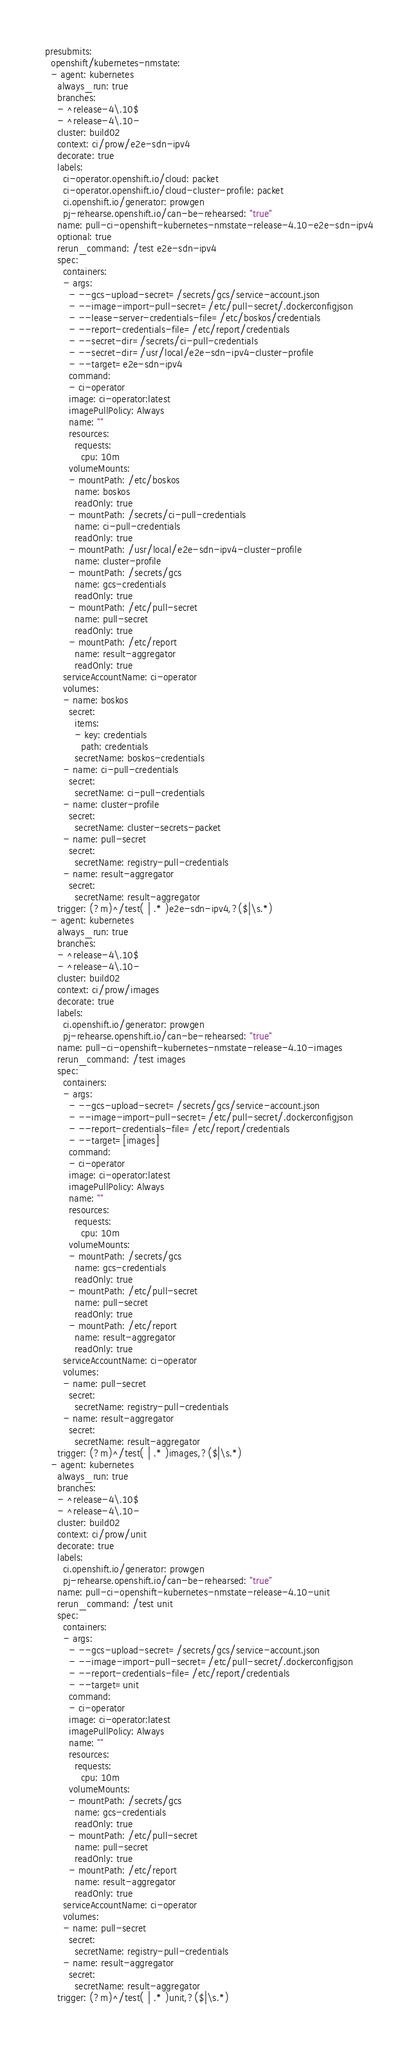<code> <loc_0><loc_0><loc_500><loc_500><_YAML_>presubmits:
  openshift/kubernetes-nmstate:
  - agent: kubernetes
    always_run: true
    branches:
    - ^release-4\.10$
    - ^release-4\.10-
    cluster: build02
    context: ci/prow/e2e-sdn-ipv4
    decorate: true
    labels:
      ci-operator.openshift.io/cloud: packet
      ci-operator.openshift.io/cloud-cluster-profile: packet
      ci.openshift.io/generator: prowgen
      pj-rehearse.openshift.io/can-be-rehearsed: "true"
    name: pull-ci-openshift-kubernetes-nmstate-release-4.10-e2e-sdn-ipv4
    optional: true
    rerun_command: /test e2e-sdn-ipv4
    spec:
      containers:
      - args:
        - --gcs-upload-secret=/secrets/gcs/service-account.json
        - --image-import-pull-secret=/etc/pull-secret/.dockerconfigjson
        - --lease-server-credentials-file=/etc/boskos/credentials
        - --report-credentials-file=/etc/report/credentials
        - --secret-dir=/secrets/ci-pull-credentials
        - --secret-dir=/usr/local/e2e-sdn-ipv4-cluster-profile
        - --target=e2e-sdn-ipv4
        command:
        - ci-operator
        image: ci-operator:latest
        imagePullPolicy: Always
        name: ""
        resources:
          requests:
            cpu: 10m
        volumeMounts:
        - mountPath: /etc/boskos
          name: boskos
          readOnly: true
        - mountPath: /secrets/ci-pull-credentials
          name: ci-pull-credentials
          readOnly: true
        - mountPath: /usr/local/e2e-sdn-ipv4-cluster-profile
          name: cluster-profile
        - mountPath: /secrets/gcs
          name: gcs-credentials
          readOnly: true
        - mountPath: /etc/pull-secret
          name: pull-secret
          readOnly: true
        - mountPath: /etc/report
          name: result-aggregator
          readOnly: true
      serviceAccountName: ci-operator
      volumes:
      - name: boskos
        secret:
          items:
          - key: credentials
            path: credentials
          secretName: boskos-credentials
      - name: ci-pull-credentials
        secret:
          secretName: ci-pull-credentials
      - name: cluster-profile
        secret:
          secretName: cluster-secrets-packet
      - name: pull-secret
        secret:
          secretName: registry-pull-credentials
      - name: result-aggregator
        secret:
          secretName: result-aggregator
    trigger: (?m)^/test( | .* )e2e-sdn-ipv4,?($|\s.*)
  - agent: kubernetes
    always_run: true
    branches:
    - ^release-4\.10$
    - ^release-4\.10-
    cluster: build02
    context: ci/prow/images
    decorate: true
    labels:
      ci.openshift.io/generator: prowgen
      pj-rehearse.openshift.io/can-be-rehearsed: "true"
    name: pull-ci-openshift-kubernetes-nmstate-release-4.10-images
    rerun_command: /test images
    spec:
      containers:
      - args:
        - --gcs-upload-secret=/secrets/gcs/service-account.json
        - --image-import-pull-secret=/etc/pull-secret/.dockerconfigjson
        - --report-credentials-file=/etc/report/credentials
        - --target=[images]
        command:
        - ci-operator
        image: ci-operator:latest
        imagePullPolicy: Always
        name: ""
        resources:
          requests:
            cpu: 10m
        volumeMounts:
        - mountPath: /secrets/gcs
          name: gcs-credentials
          readOnly: true
        - mountPath: /etc/pull-secret
          name: pull-secret
          readOnly: true
        - mountPath: /etc/report
          name: result-aggregator
          readOnly: true
      serviceAccountName: ci-operator
      volumes:
      - name: pull-secret
        secret:
          secretName: registry-pull-credentials
      - name: result-aggregator
        secret:
          secretName: result-aggregator
    trigger: (?m)^/test( | .* )images,?($|\s.*)
  - agent: kubernetes
    always_run: true
    branches:
    - ^release-4\.10$
    - ^release-4\.10-
    cluster: build02
    context: ci/prow/unit
    decorate: true
    labels:
      ci.openshift.io/generator: prowgen
      pj-rehearse.openshift.io/can-be-rehearsed: "true"
    name: pull-ci-openshift-kubernetes-nmstate-release-4.10-unit
    rerun_command: /test unit
    spec:
      containers:
      - args:
        - --gcs-upload-secret=/secrets/gcs/service-account.json
        - --image-import-pull-secret=/etc/pull-secret/.dockerconfigjson
        - --report-credentials-file=/etc/report/credentials
        - --target=unit
        command:
        - ci-operator
        image: ci-operator:latest
        imagePullPolicy: Always
        name: ""
        resources:
          requests:
            cpu: 10m
        volumeMounts:
        - mountPath: /secrets/gcs
          name: gcs-credentials
          readOnly: true
        - mountPath: /etc/pull-secret
          name: pull-secret
          readOnly: true
        - mountPath: /etc/report
          name: result-aggregator
          readOnly: true
      serviceAccountName: ci-operator
      volumes:
      - name: pull-secret
        secret:
          secretName: registry-pull-credentials
      - name: result-aggregator
        secret:
          secretName: result-aggregator
    trigger: (?m)^/test( | .* )unit,?($|\s.*)
</code> 